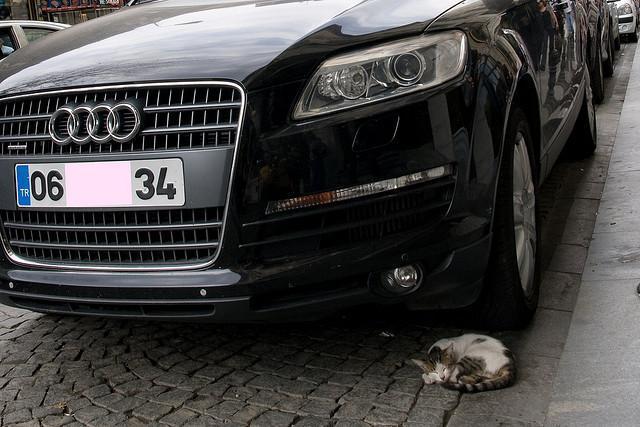How many cars can be seen?
Give a very brief answer. 2. How many people are climbing the stairs?
Give a very brief answer. 0. 